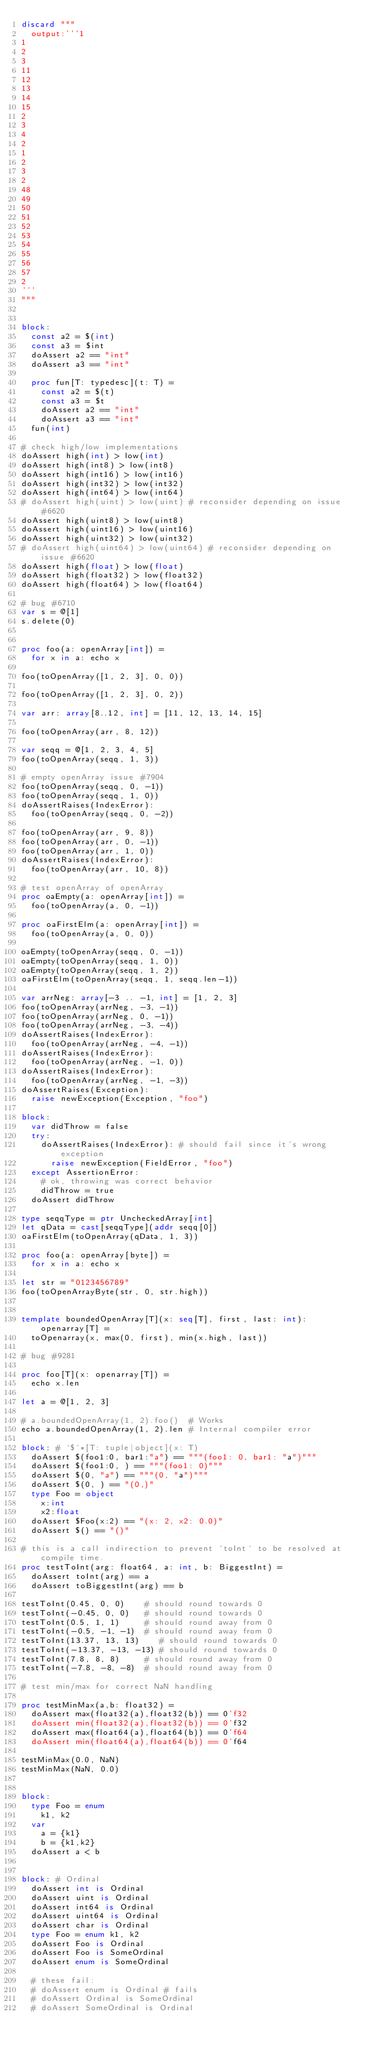Convert code to text. <code><loc_0><loc_0><loc_500><loc_500><_Nim_>discard """
  output:'''1
1
2
3
11
12
13
14
15
2
3
4
2
1
2
3
2
48
49
50
51
52
53
54
55
56
57
2
'''
"""


block:
  const a2 = $(int)
  const a3 = $int
  doAssert a2 == "int"
  doAssert a3 == "int"

  proc fun[T: typedesc](t: T) =
    const a2 = $(t)
    const a3 = $t
    doAssert a2 == "int"
    doAssert a3 == "int"
  fun(int)

# check high/low implementations
doAssert high(int) > low(int)
doAssert high(int8) > low(int8)
doAssert high(int16) > low(int16)
doAssert high(int32) > low(int32)
doAssert high(int64) > low(int64)
# doAssert high(uint) > low(uint) # reconsider depending on issue #6620
doAssert high(uint8) > low(uint8)
doAssert high(uint16) > low(uint16)
doAssert high(uint32) > low(uint32)
# doAssert high(uint64) > low(uint64) # reconsider depending on issue #6620
doAssert high(float) > low(float)
doAssert high(float32) > low(float32)
doAssert high(float64) > low(float64)

# bug #6710
var s = @[1]
s.delete(0)


proc foo(a: openArray[int]) =
  for x in a: echo x

foo(toOpenArray([1, 2, 3], 0, 0))

foo(toOpenArray([1, 2, 3], 0, 2))

var arr: array[8..12, int] = [11, 12, 13, 14, 15]

foo(toOpenArray(arr, 8, 12))

var seqq = @[1, 2, 3, 4, 5]
foo(toOpenArray(seqq, 1, 3))

# empty openArray issue #7904
foo(toOpenArray(seqq, 0, -1))
foo(toOpenArray(seqq, 1, 0))
doAssertRaises(IndexError):
  foo(toOpenArray(seqq, 0, -2))

foo(toOpenArray(arr, 9, 8))
foo(toOpenArray(arr, 0, -1))
foo(toOpenArray(arr, 1, 0))
doAssertRaises(IndexError):
  foo(toOpenArray(arr, 10, 8))

# test openArray of openArray
proc oaEmpty(a: openArray[int]) =
  foo(toOpenArray(a, 0, -1))

proc oaFirstElm(a: openArray[int]) =
  foo(toOpenArray(a, 0, 0))

oaEmpty(toOpenArray(seqq, 0, -1))
oaEmpty(toOpenArray(seqq, 1, 0))
oaEmpty(toOpenArray(seqq, 1, 2))
oaFirstElm(toOpenArray(seqq, 1, seqq.len-1))

var arrNeg: array[-3 .. -1, int] = [1, 2, 3]
foo(toOpenArray(arrNeg, -3, -1))
foo(toOpenArray(arrNeg, 0, -1))
foo(toOpenArray(arrNeg, -3, -4))
doAssertRaises(IndexError):
  foo(toOpenArray(arrNeg, -4, -1))
doAssertRaises(IndexError):
  foo(toOpenArray(arrNeg, -1, 0))
doAssertRaises(IndexError):
  foo(toOpenArray(arrNeg, -1, -3))
doAssertRaises(Exception):
  raise newException(Exception, "foo")

block:
  var didThrow = false
  try:
    doAssertRaises(IndexError): # should fail since it's wrong exception
      raise newException(FieldError, "foo")
  except AssertionError:
    # ok, throwing was correct behavior
    didThrow = true
  doAssert didThrow

type seqqType = ptr UncheckedArray[int]
let qData = cast[seqqType](addr seqq[0])
oaFirstElm(toOpenArray(qData, 1, 3))

proc foo(a: openArray[byte]) =
  for x in a: echo x

let str = "0123456789"
foo(toOpenArrayByte(str, 0, str.high))


template boundedOpenArray[T](x: seq[T], first, last: int): openarray[T] =
  toOpenarray(x, max(0, first), min(x.high, last))

# bug #9281

proc foo[T](x: openarray[T]) =
  echo x.len

let a = @[1, 2, 3]

# a.boundedOpenArray(1, 2).foo()  # Works
echo a.boundedOpenArray(1, 2).len # Internal compiler error

block: # `$`*[T: tuple|object](x: T)
  doAssert $(foo1:0, bar1:"a") == """(foo1: 0, bar1: "a")"""
  doAssert $(foo1:0, ) == """(foo1: 0)"""
  doAssert $(0, "a") == """(0, "a")"""
  doAssert $(0, ) == "(0,)"
  type Foo = object
    x:int
    x2:float
  doAssert $Foo(x:2) == "(x: 2, x2: 0.0)"
  doAssert $() == "()"

# this is a call indirection to prevent `toInt` to be resolved at compile time.
proc testToInt(arg: float64, a: int, b: BiggestInt) =
  doAssert toInt(arg) == a
  doAssert toBiggestInt(arg) == b

testToInt(0.45, 0, 0)    # should round towards 0
testToInt(-0.45, 0, 0)   # should round towards 0
testToInt(0.5, 1, 1)     # should round away from 0
testToInt(-0.5, -1, -1)  # should round away from 0
testToInt(13.37, 13, 13)    # should round towards 0
testToInt(-13.37, -13, -13) # should round towards 0
testToInt(7.8, 8, 8)     # should round away from 0
testToInt(-7.8, -8, -8)  # should round away from 0

# test min/max for correct NaN handling

proc testMinMax(a,b: float32) =
  doAssert max(float32(a),float32(b)) == 0'f32
  doAssert min(float32(a),float32(b)) == 0'f32
  doAssert max(float64(a),float64(b)) == 0'f64
  doAssert min(float64(a),float64(b)) == 0'f64

testMinMax(0.0, NaN)
testMinMax(NaN, 0.0)


block:
  type Foo = enum
    k1, k2
  var
    a = {k1}
    b = {k1,k2}
  doAssert a < b


block: # Ordinal
  doAssert int is Ordinal
  doAssert uint is Ordinal
  doAssert int64 is Ordinal
  doAssert uint64 is Ordinal
  doAssert char is Ordinal
  type Foo = enum k1, k2
  doAssert Foo is Ordinal
  doAssert Foo is SomeOrdinal
  doAssert enum is SomeOrdinal

  # these fail:
  # doAssert enum is Ordinal # fails
  # doAssert Ordinal is SomeOrdinal
  # doAssert SomeOrdinal is Ordinal
</code> 